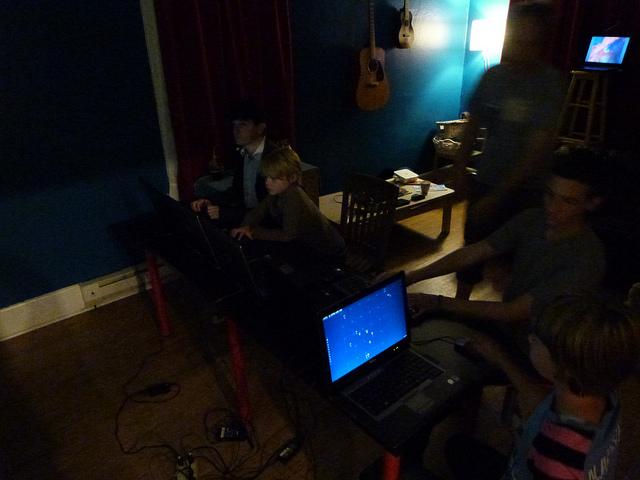Is the room very dark?
Quick response, please. Yes. How many laptops are seen?
Write a very short answer. 4. Are the laptops on?
Quick response, please. Yes. 